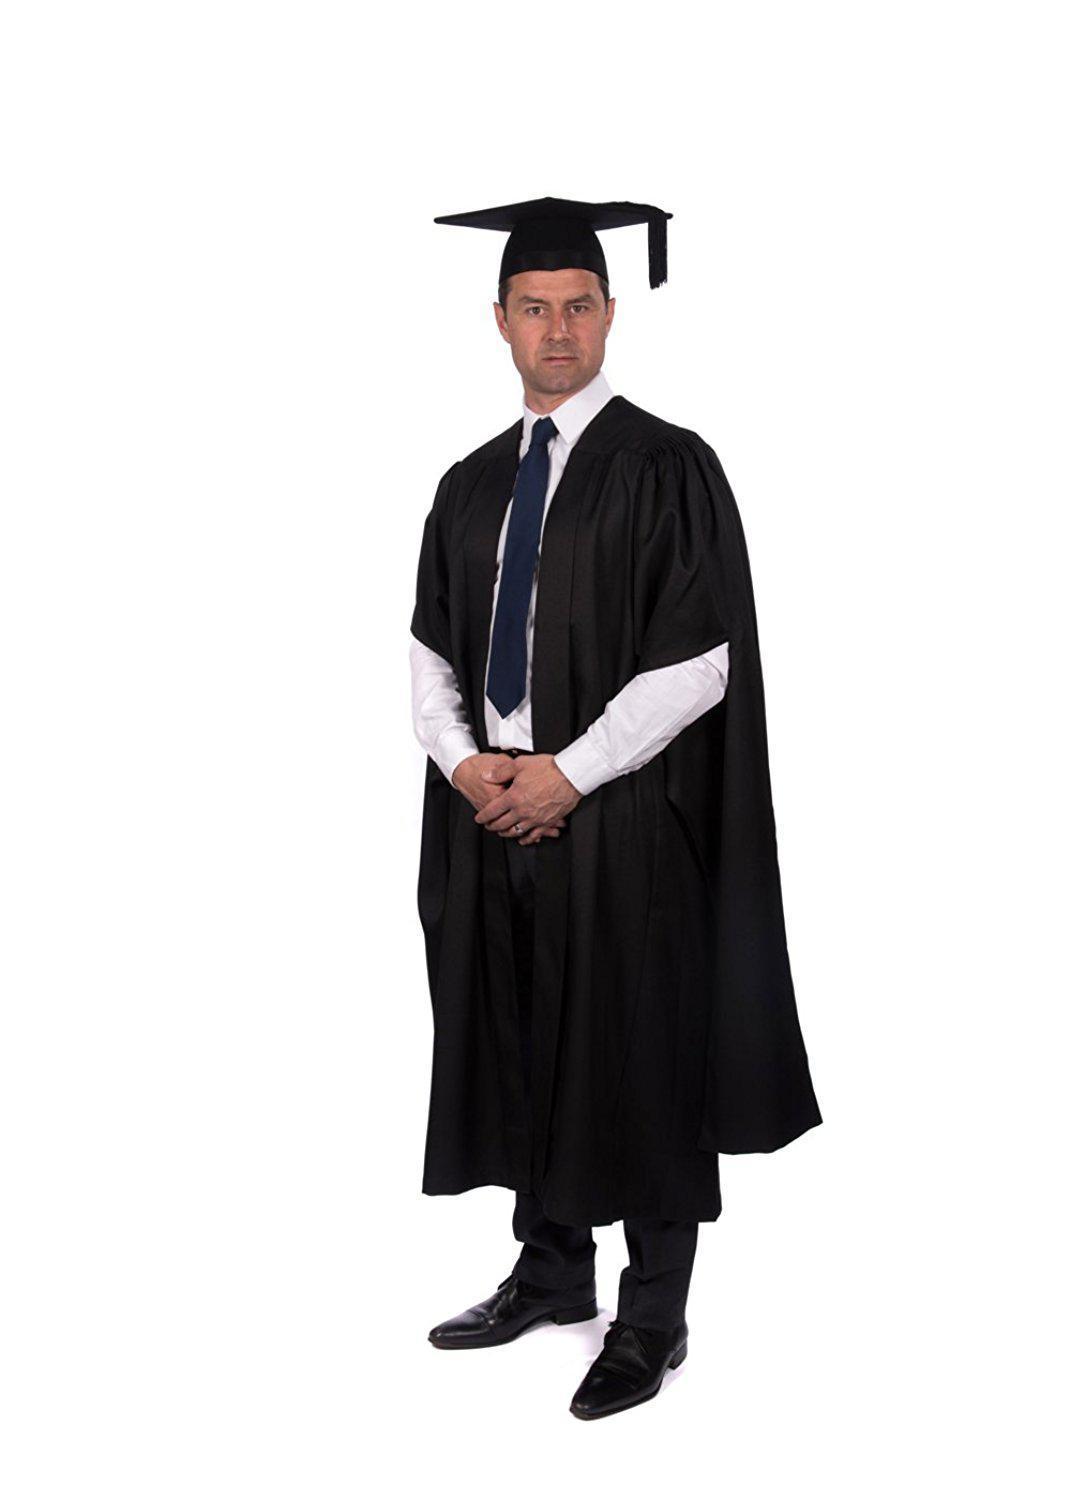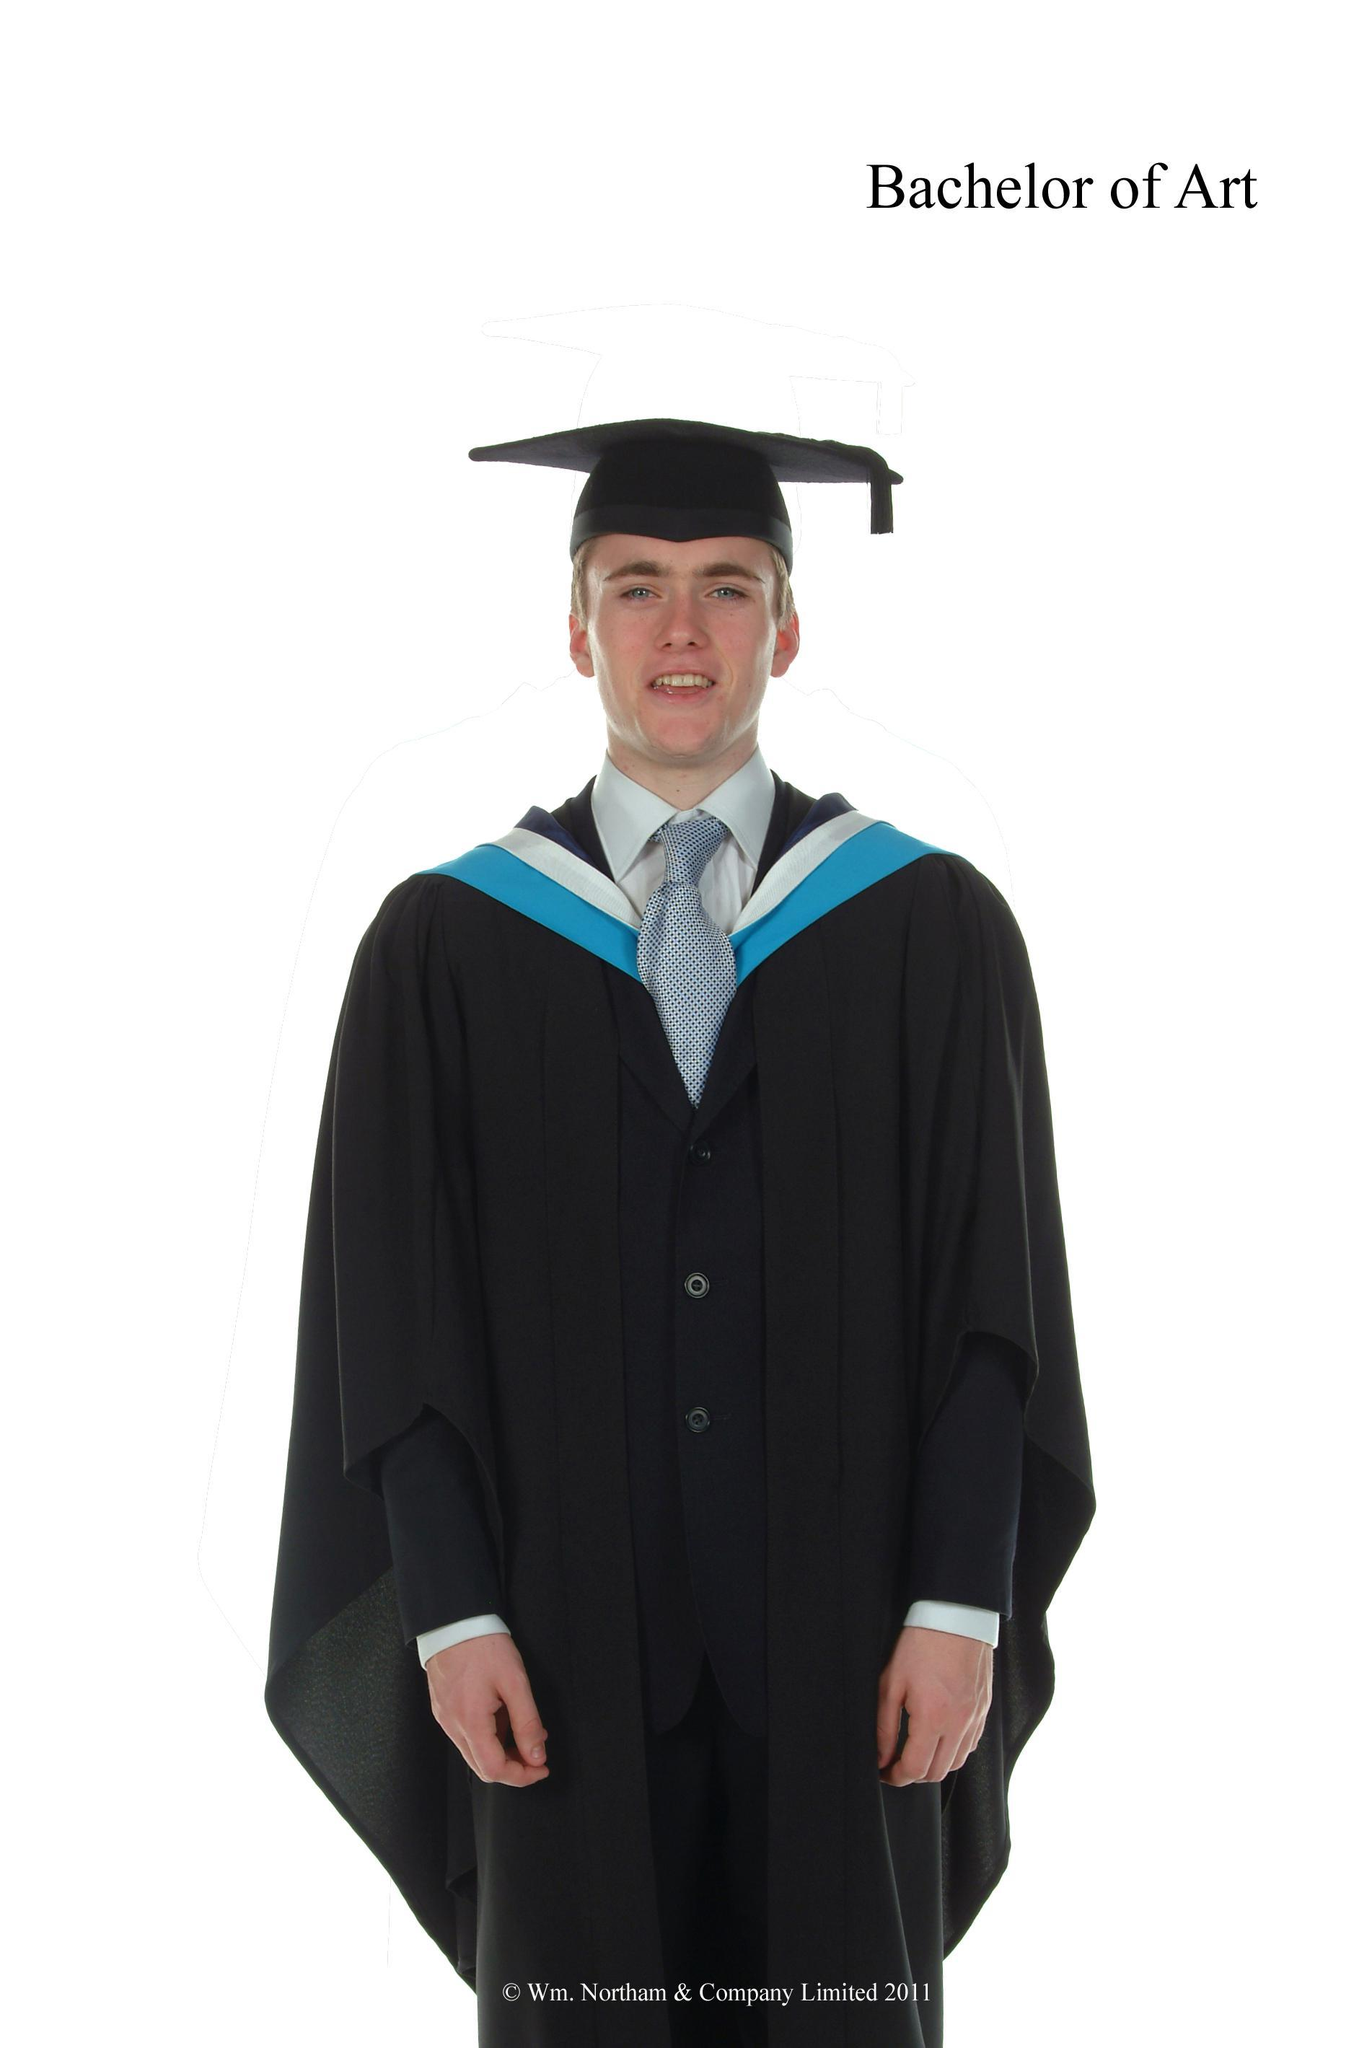The first image is the image on the left, the second image is the image on the right. Examine the images to the left and right. Is the description "There is a man on the left and a woman on the right in both images." accurate? Answer yes or no. No. The first image is the image on the left, the second image is the image on the right. Examine the images to the left and right. Is the description "There is a female in the right image." accurate? Answer yes or no. No. 